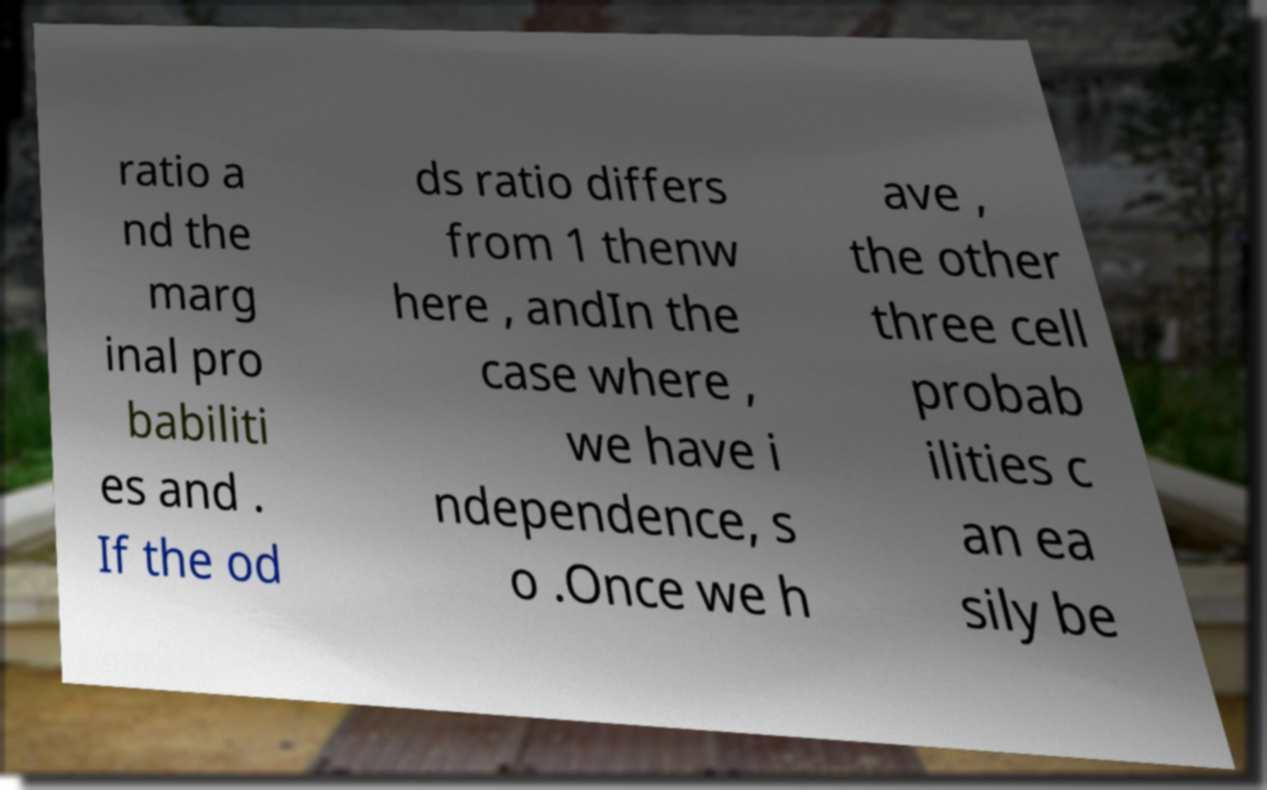Could you assist in decoding the text presented in this image and type it out clearly? ratio a nd the marg inal pro babiliti es and . If the od ds ratio differs from 1 thenw here , andIn the case where , we have i ndependence, s o .Once we h ave , the other three cell probab ilities c an ea sily be 